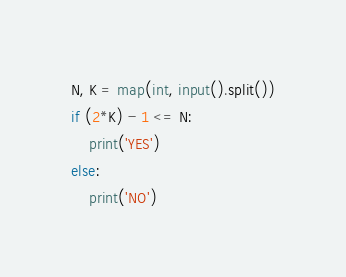<code> <loc_0><loc_0><loc_500><loc_500><_Python_>N, K = map(int, input().split())
if (2*K) - 1 <= N:
    print('YES')
else:
    print('NO')
</code> 